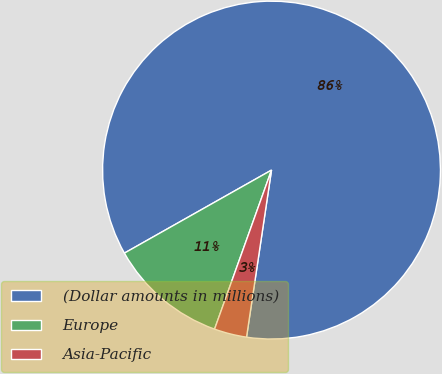Convert chart. <chart><loc_0><loc_0><loc_500><loc_500><pie_chart><fcel>(Dollar amounts in millions)<fcel>Europe<fcel>Asia-Pacific<nl><fcel>85.55%<fcel>11.35%<fcel>3.11%<nl></chart> 